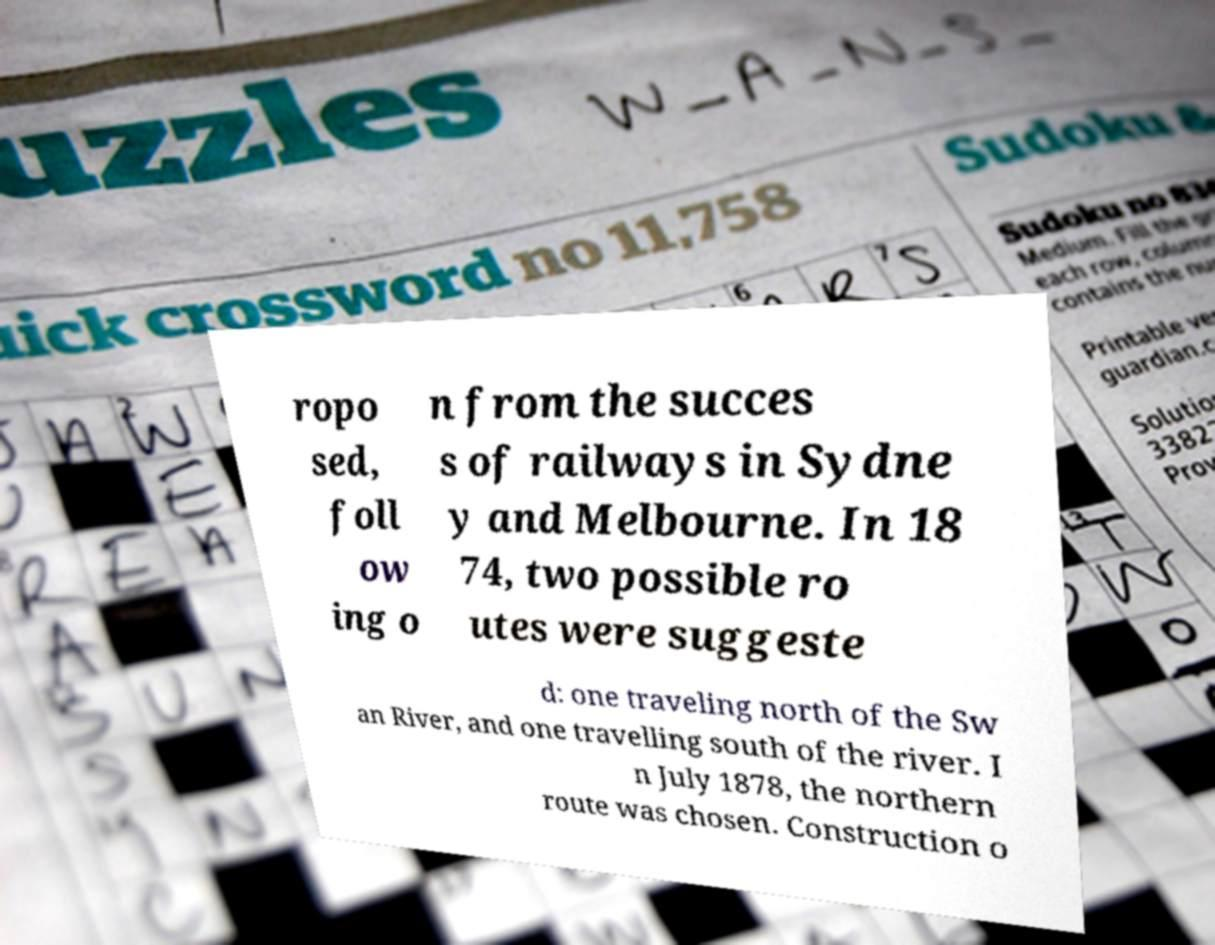I need the written content from this picture converted into text. Can you do that? ropo sed, foll ow ing o n from the succes s of railways in Sydne y and Melbourne. In 18 74, two possible ro utes were suggeste d: one traveling north of the Sw an River, and one travelling south of the river. I n July 1878, the northern route was chosen. Construction o 